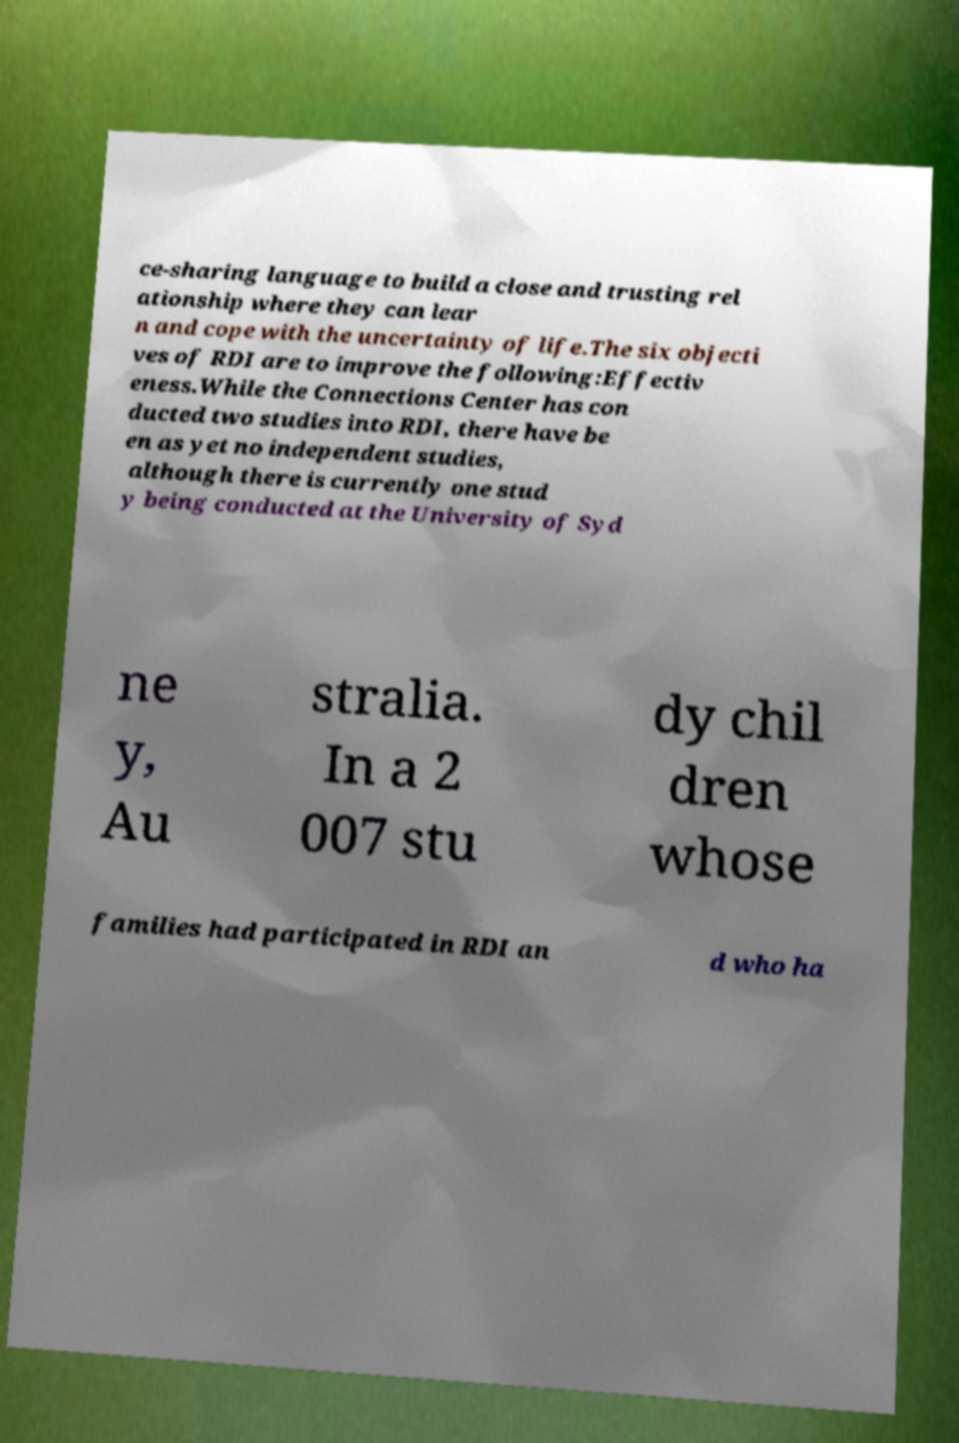Can you accurately transcribe the text from the provided image for me? ce-sharing language to build a close and trusting rel ationship where they can lear n and cope with the uncertainty of life.The six objecti ves of RDI are to improve the following:Effectiv eness.While the Connections Center has con ducted two studies into RDI, there have be en as yet no independent studies, although there is currently one stud y being conducted at the University of Syd ne y, Au stralia. In a 2 007 stu dy chil dren whose families had participated in RDI an d who ha 